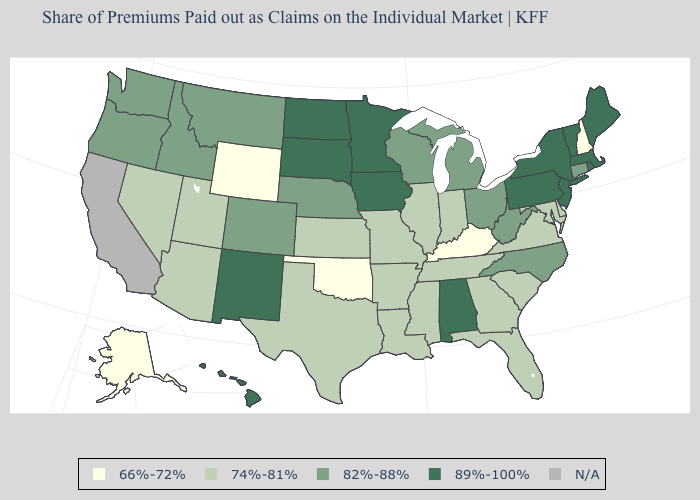Name the states that have a value in the range N/A?
Keep it brief. California. Name the states that have a value in the range 82%-88%?
Concise answer only. Colorado, Connecticut, Idaho, Michigan, Montana, Nebraska, North Carolina, Ohio, Oregon, Washington, West Virginia, Wisconsin. Name the states that have a value in the range 74%-81%?
Write a very short answer. Arizona, Arkansas, Delaware, Florida, Georgia, Illinois, Indiana, Kansas, Louisiana, Maryland, Mississippi, Missouri, Nevada, South Carolina, Tennessee, Texas, Utah, Virginia. Does the map have missing data?
Short answer required. Yes. What is the lowest value in the MidWest?
Answer briefly. 74%-81%. What is the highest value in the USA?
Give a very brief answer. 89%-100%. What is the lowest value in the USA?
Quick response, please. 66%-72%. Is the legend a continuous bar?
Be succinct. No. Does the map have missing data?
Write a very short answer. Yes. Does the map have missing data?
Be succinct. Yes. Is the legend a continuous bar?
Answer briefly. No. What is the value of Utah?
Quick response, please. 74%-81%. Name the states that have a value in the range 74%-81%?
Keep it brief. Arizona, Arkansas, Delaware, Florida, Georgia, Illinois, Indiana, Kansas, Louisiana, Maryland, Mississippi, Missouri, Nevada, South Carolina, Tennessee, Texas, Utah, Virginia. Which states have the lowest value in the USA?
Give a very brief answer. Alaska, Kentucky, New Hampshire, Oklahoma, Wyoming. 